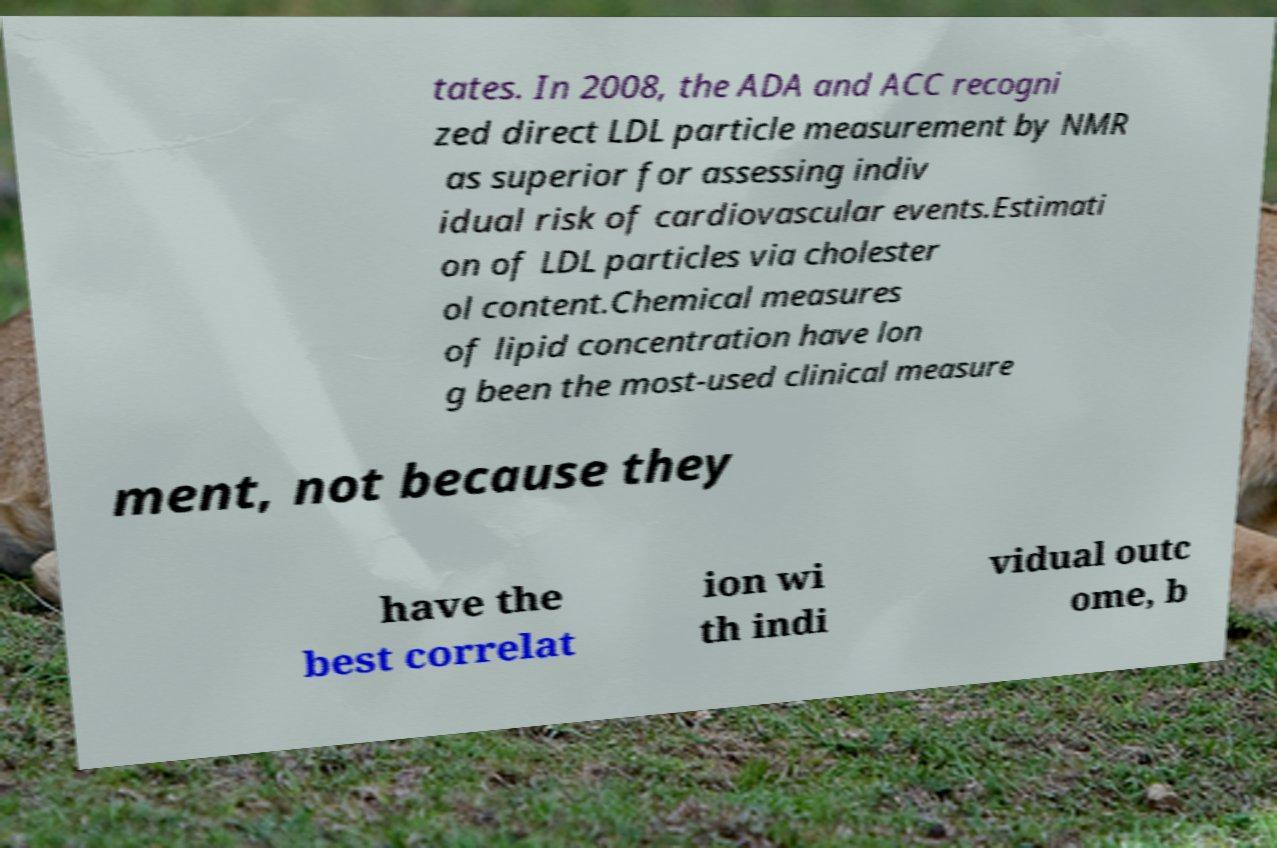Could you assist in decoding the text presented in this image and type it out clearly? tates. In 2008, the ADA and ACC recogni zed direct LDL particle measurement by NMR as superior for assessing indiv idual risk of cardiovascular events.Estimati on of LDL particles via cholester ol content.Chemical measures of lipid concentration have lon g been the most-used clinical measure ment, not because they have the best correlat ion wi th indi vidual outc ome, b 